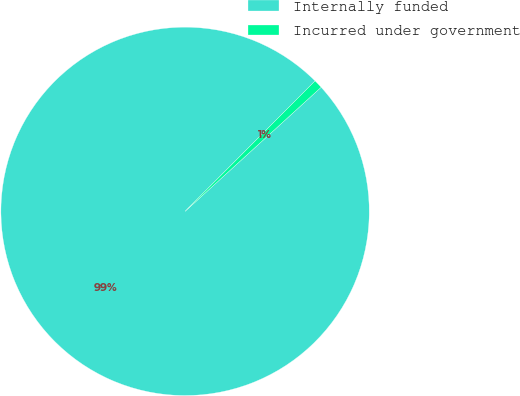<chart> <loc_0><loc_0><loc_500><loc_500><pie_chart><fcel>Internally funded<fcel>Incurred under government<nl><fcel>99.24%<fcel>0.76%<nl></chart> 